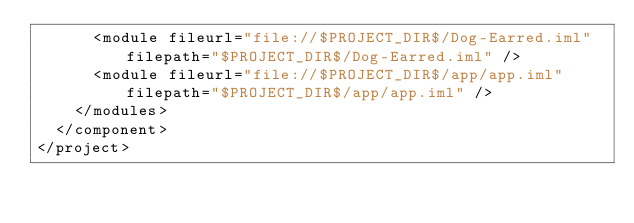<code> <loc_0><loc_0><loc_500><loc_500><_XML_>      <module fileurl="file://$PROJECT_DIR$/Dog-Earred.iml" filepath="$PROJECT_DIR$/Dog-Earred.iml" />
      <module fileurl="file://$PROJECT_DIR$/app/app.iml" filepath="$PROJECT_DIR$/app/app.iml" />
    </modules>
  </component>
</project>

</code> 